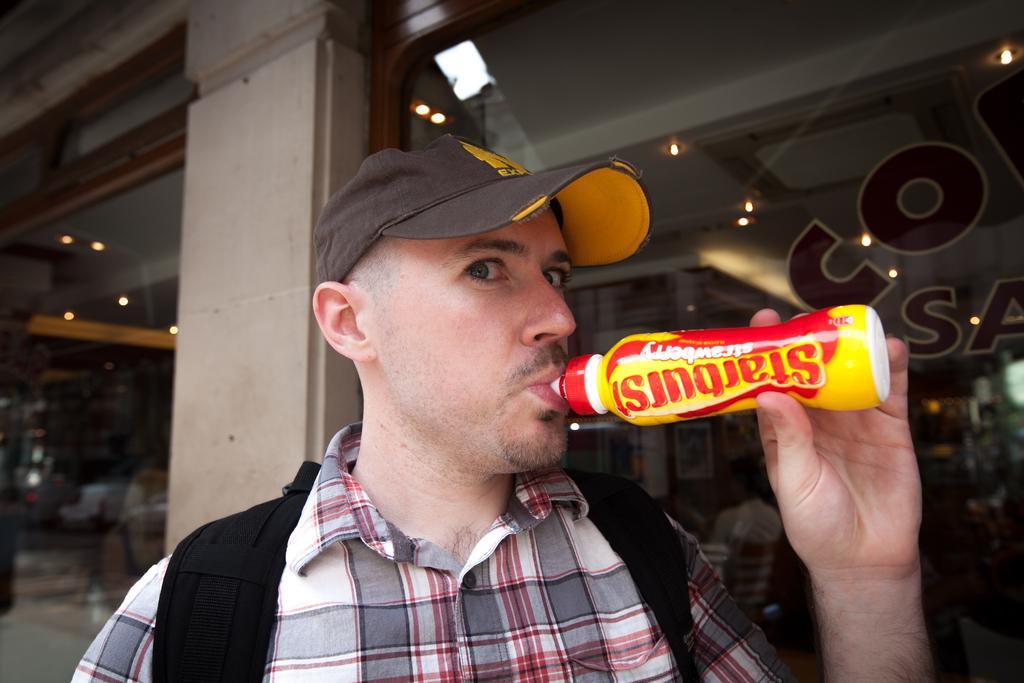How would you summarize this image in a sentence or two? In the image there is a man and he is drinking some drink, behind the man there are two glasses, in between the glasses there is a wall. 